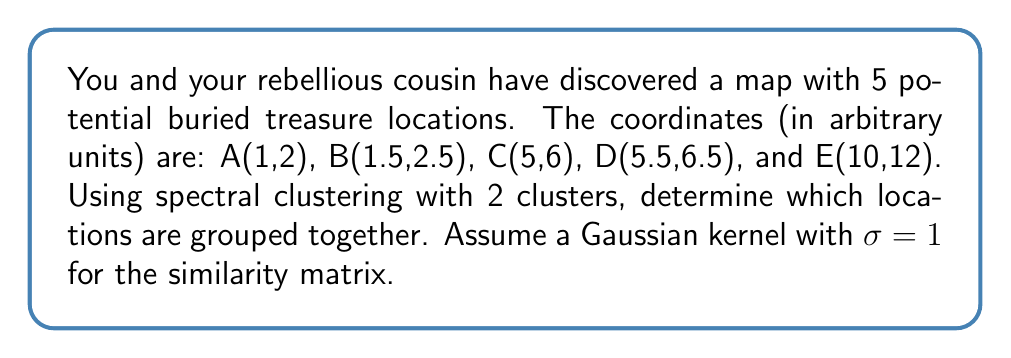Help me with this question. Let's approach this step-by-step:

1) First, we need to construct the similarity matrix using the Gaussian kernel. The formula for the similarity between two points $x_i$ and $x_j$ is:

   $$S_{ij} = e^{-\frac{||x_i - x_j||^2}{2\sigma^2}}$$

2) Calculate the distances between each pair of points:
   
   $$||A-B|| = \sqrt{(1.5-1)^2 + (2.5-2)^2} = 0.707$$
   $$||A-C|| = \sqrt{(5-1)^2 + (6-2)^2} = 5.657$$
   $$||A-D|| = \sqrt{(5.5-1)^2 + (6.5-2)^2} = 6.364$$
   $$||A-E|| = \sqrt{(10-1)^2 + (12-2)^2} = 13.416$$
   $$||B-C|| = \sqrt{(5-1.5)^2 + (6-2.5)^2} = 5$$
   $$||B-D|| = \sqrt{(5.5-1.5)^2 + (6.5-2.5)^2} = 5.701$$
   $$||B-E|| = \sqrt{(10-1.5)^2 + (12-2.5)^2} = 12.748$$
   $$||C-D|| = \sqrt{(5.5-5)^2 + (6.5-6)^2} = 0.707$$
   $$||C-E|| = \sqrt{(10-5)^2 + (12-6)^2} = 7.810$$
   $$||D-E|| = \sqrt{(10-5.5)^2 + (12-6.5)^2} = 7.106$$

3) Now, construct the similarity matrix:

   $$S = \begin{bmatrix}
   1 & 0.779 & 0.204 & 0.132 & 0.011 \\
   0.779 & 1 & 0.286 & 0.193 & 0.020 \\
   0.204 & 0.286 & 1 & 0.779 & 0.048 \\
   0.132 & 0.193 & 0.779 & 1 & 0.082 \\
   0.011 & 0.020 & 0.048 & 0.082 & 1
   \end{bmatrix}$$

4) Compute the diagonal degree matrix D:

   $$D = \begin{bmatrix}
   2.126 & 0 & 0 & 0 & 0 \\
   0 & 2.278 & 0 & 0 & 0 \\
   0 & 0 & 2.317 & 0 & 0 \\
   0 & 0 & 0 & 2.186 & 0 \\
   0 & 0 & 0 & 0 & 1.161
   \end{bmatrix}$$

5) Calculate the Laplacian matrix L = D - S:

   $$L = \begin{bmatrix}
   1.126 & -0.779 & -0.204 & -0.132 & -0.011 \\
   -0.779 & 1.278 & -0.286 & -0.193 & -0.020 \\
   -0.204 & -0.286 & 1.317 & -0.779 & -0.048 \\
   -0.132 & -0.193 & -0.779 & 1.186 & -0.082 \\
   -0.011 & -0.020 & -0.048 & -0.082 & 0.161
   \end{bmatrix}$$

6) Find the eigenvectors of L. The second smallest eigenvector will be used for clustering:

   $$v_2 = [-0.478, -0.525, 0.362, 0.403, 0.445]^T$$

7) The sign of each component in $v_2$ determines the cluster assignment. Negative values belong to one cluster, positive to the other.
Answer: Cluster 1: A, B; Cluster 2: C, D, E 